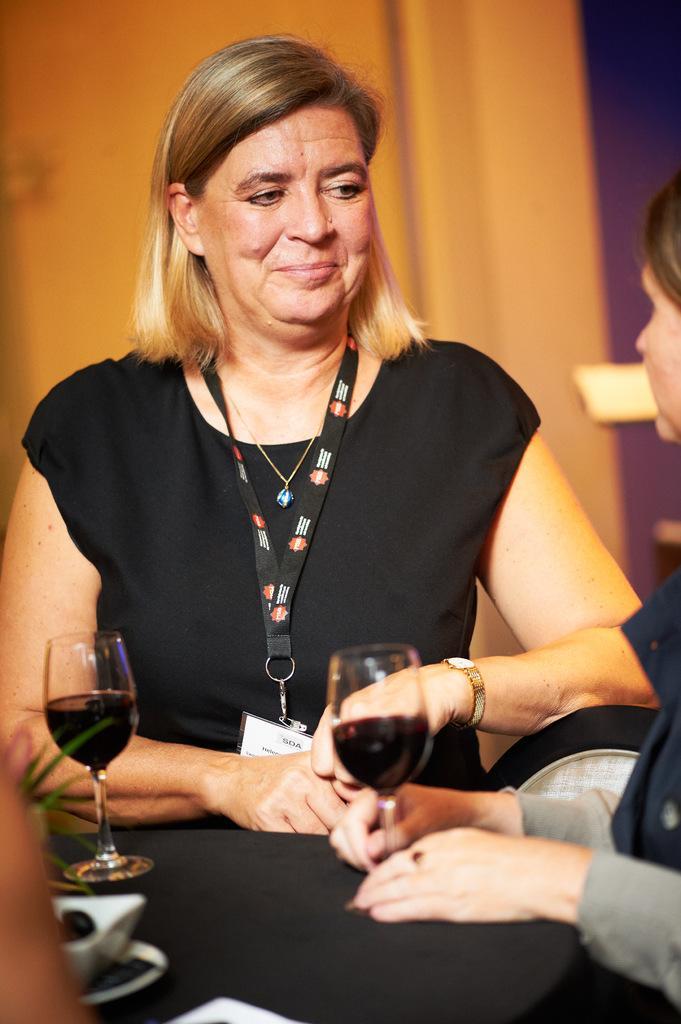How would you summarize this image in a sentence or two? In the middle of this image, there is a woman in a black color dress, wearing a badge, smiling in front of a table, on which there are two glasses filled with drink and other objects. On the right side, there is another woman. And the background is blurred. 